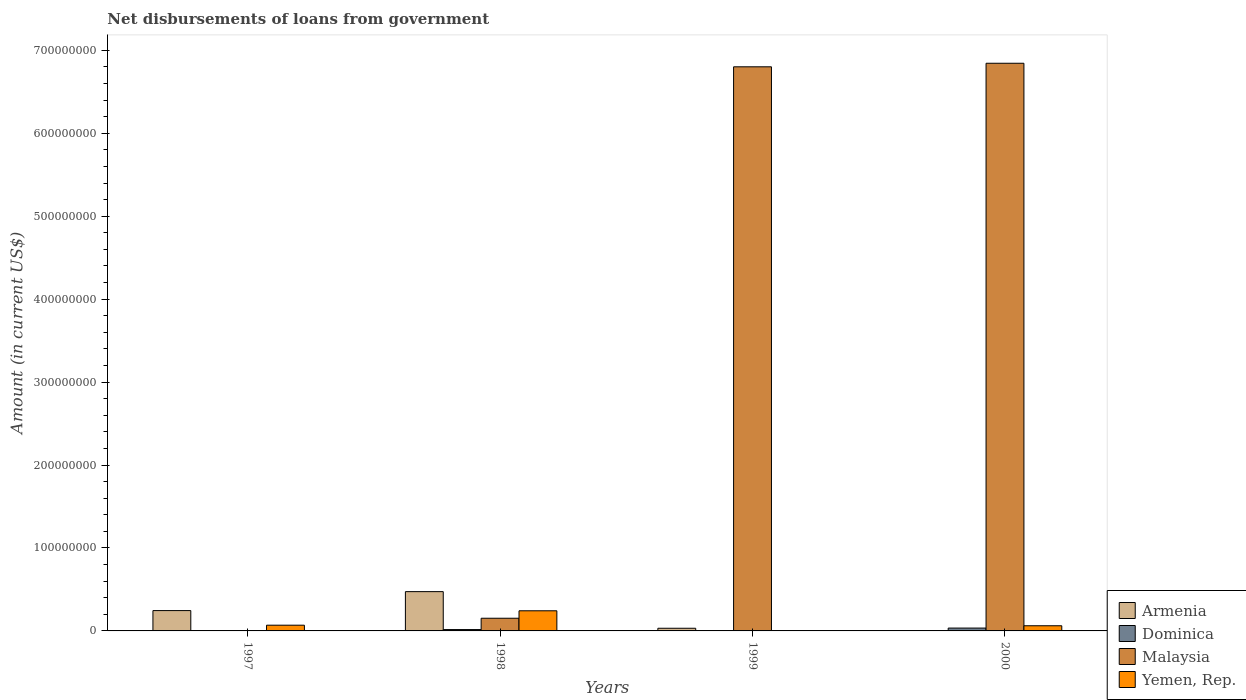How many different coloured bars are there?
Your answer should be very brief. 4. Are the number of bars per tick equal to the number of legend labels?
Make the answer very short. No. How many bars are there on the 1st tick from the left?
Provide a short and direct response. 2. How many bars are there on the 3rd tick from the right?
Provide a short and direct response. 4. What is the label of the 1st group of bars from the left?
Ensure brevity in your answer.  1997. What is the amount of loan disbursed from government in Dominica in 1999?
Offer a terse response. 0. Across all years, what is the maximum amount of loan disbursed from government in Yemen, Rep.?
Give a very brief answer. 2.43e+07. In which year was the amount of loan disbursed from government in Yemen, Rep. maximum?
Your response must be concise. 1998. What is the total amount of loan disbursed from government in Malaysia in the graph?
Keep it short and to the point. 1.38e+09. What is the difference between the amount of loan disbursed from government in Yemen, Rep. in 1997 and that in 2000?
Offer a terse response. 6.73e+05. What is the difference between the amount of loan disbursed from government in Armenia in 1998 and the amount of loan disbursed from government in Malaysia in 1997?
Ensure brevity in your answer.  4.74e+07. What is the average amount of loan disbursed from government in Malaysia per year?
Provide a succinct answer. 3.45e+08. In the year 1998, what is the difference between the amount of loan disbursed from government in Dominica and amount of loan disbursed from government in Malaysia?
Give a very brief answer. -1.37e+07. What is the ratio of the amount of loan disbursed from government in Armenia in 1997 to that in 1998?
Your answer should be very brief. 0.52. Is the difference between the amount of loan disbursed from government in Dominica in 1998 and 2000 greater than the difference between the amount of loan disbursed from government in Malaysia in 1998 and 2000?
Your answer should be compact. Yes. What is the difference between the highest and the second highest amount of loan disbursed from government in Armenia?
Your answer should be very brief. 2.28e+07. What is the difference between the highest and the lowest amount of loan disbursed from government in Armenia?
Give a very brief answer. 4.74e+07. In how many years, is the amount of loan disbursed from government in Armenia greater than the average amount of loan disbursed from government in Armenia taken over all years?
Offer a terse response. 2. Is the sum of the amount of loan disbursed from government in Malaysia in 1998 and 1999 greater than the maximum amount of loan disbursed from government in Dominica across all years?
Your answer should be compact. Yes. Is it the case that in every year, the sum of the amount of loan disbursed from government in Yemen, Rep. and amount of loan disbursed from government in Armenia is greater than the sum of amount of loan disbursed from government in Dominica and amount of loan disbursed from government in Malaysia?
Make the answer very short. No. Is it the case that in every year, the sum of the amount of loan disbursed from government in Malaysia and amount of loan disbursed from government in Yemen, Rep. is greater than the amount of loan disbursed from government in Armenia?
Give a very brief answer. No. What is the difference between two consecutive major ticks on the Y-axis?
Provide a succinct answer. 1.00e+08. Are the values on the major ticks of Y-axis written in scientific E-notation?
Your answer should be compact. No. Does the graph contain any zero values?
Keep it short and to the point. Yes. Does the graph contain grids?
Provide a short and direct response. No. Where does the legend appear in the graph?
Ensure brevity in your answer.  Bottom right. How many legend labels are there?
Give a very brief answer. 4. What is the title of the graph?
Offer a very short reply. Net disbursements of loans from government. Does "Cameroon" appear as one of the legend labels in the graph?
Provide a succinct answer. No. What is the label or title of the Y-axis?
Provide a short and direct response. Amount (in current US$). What is the Amount (in current US$) of Armenia in 1997?
Give a very brief answer. 2.45e+07. What is the Amount (in current US$) in Dominica in 1997?
Give a very brief answer. 0. What is the Amount (in current US$) of Yemen, Rep. in 1997?
Provide a succinct answer. 6.90e+06. What is the Amount (in current US$) in Armenia in 1998?
Offer a very short reply. 4.74e+07. What is the Amount (in current US$) of Dominica in 1998?
Your answer should be very brief. 1.63e+06. What is the Amount (in current US$) of Malaysia in 1998?
Make the answer very short. 1.53e+07. What is the Amount (in current US$) of Yemen, Rep. in 1998?
Your response must be concise. 2.43e+07. What is the Amount (in current US$) in Armenia in 1999?
Make the answer very short. 3.22e+06. What is the Amount (in current US$) of Malaysia in 1999?
Provide a short and direct response. 6.80e+08. What is the Amount (in current US$) of Dominica in 2000?
Your answer should be very brief. 3.44e+06. What is the Amount (in current US$) in Malaysia in 2000?
Give a very brief answer. 6.84e+08. What is the Amount (in current US$) of Yemen, Rep. in 2000?
Offer a terse response. 6.22e+06. Across all years, what is the maximum Amount (in current US$) of Armenia?
Offer a very short reply. 4.74e+07. Across all years, what is the maximum Amount (in current US$) in Dominica?
Provide a succinct answer. 3.44e+06. Across all years, what is the maximum Amount (in current US$) of Malaysia?
Provide a succinct answer. 6.84e+08. Across all years, what is the maximum Amount (in current US$) of Yemen, Rep.?
Make the answer very short. 2.43e+07. Across all years, what is the minimum Amount (in current US$) in Dominica?
Make the answer very short. 0. Across all years, what is the minimum Amount (in current US$) in Yemen, Rep.?
Your answer should be very brief. 0. What is the total Amount (in current US$) of Armenia in the graph?
Provide a succinct answer. 7.51e+07. What is the total Amount (in current US$) of Dominica in the graph?
Offer a terse response. 5.06e+06. What is the total Amount (in current US$) in Malaysia in the graph?
Make the answer very short. 1.38e+09. What is the total Amount (in current US$) in Yemen, Rep. in the graph?
Offer a terse response. 3.74e+07. What is the difference between the Amount (in current US$) of Armenia in 1997 and that in 1998?
Offer a very short reply. -2.28e+07. What is the difference between the Amount (in current US$) of Yemen, Rep. in 1997 and that in 1998?
Make the answer very short. -1.74e+07. What is the difference between the Amount (in current US$) of Armenia in 1997 and that in 1999?
Offer a very short reply. 2.13e+07. What is the difference between the Amount (in current US$) in Yemen, Rep. in 1997 and that in 2000?
Offer a very short reply. 6.73e+05. What is the difference between the Amount (in current US$) in Armenia in 1998 and that in 1999?
Make the answer very short. 4.41e+07. What is the difference between the Amount (in current US$) in Malaysia in 1998 and that in 1999?
Offer a terse response. -6.65e+08. What is the difference between the Amount (in current US$) of Dominica in 1998 and that in 2000?
Provide a short and direct response. -1.81e+06. What is the difference between the Amount (in current US$) of Malaysia in 1998 and that in 2000?
Give a very brief answer. -6.69e+08. What is the difference between the Amount (in current US$) in Yemen, Rep. in 1998 and that in 2000?
Ensure brevity in your answer.  1.81e+07. What is the difference between the Amount (in current US$) of Malaysia in 1999 and that in 2000?
Your response must be concise. -4.28e+06. What is the difference between the Amount (in current US$) of Armenia in 1997 and the Amount (in current US$) of Dominica in 1998?
Offer a very short reply. 2.29e+07. What is the difference between the Amount (in current US$) in Armenia in 1997 and the Amount (in current US$) in Malaysia in 1998?
Your response must be concise. 9.23e+06. What is the difference between the Amount (in current US$) in Armenia in 1997 and the Amount (in current US$) in Yemen, Rep. in 1998?
Offer a terse response. 2.37e+05. What is the difference between the Amount (in current US$) of Armenia in 1997 and the Amount (in current US$) of Malaysia in 1999?
Keep it short and to the point. -6.56e+08. What is the difference between the Amount (in current US$) in Armenia in 1997 and the Amount (in current US$) in Dominica in 2000?
Make the answer very short. 2.11e+07. What is the difference between the Amount (in current US$) of Armenia in 1997 and the Amount (in current US$) of Malaysia in 2000?
Give a very brief answer. -6.60e+08. What is the difference between the Amount (in current US$) in Armenia in 1997 and the Amount (in current US$) in Yemen, Rep. in 2000?
Ensure brevity in your answer.  1.83e+07. What is the difference between the Amount (in current US$) of Armenia in 1998 and the Amount (in current US$) of Malaysia in 1999?
Give a very brief answer. -6.33e+08. What is the difference between the Amount (in current US$) in Dominica in 1998 and the Amount (in current US$) in Malaysia in 1999?
Ensure brevity in your answer.  -6.79e+08. What is the difference between the Amount (in current US$) of Armenia in 1998 and the Amount (in current US$) of Dominica in 2000?
Provide a succinct answer. 4.39e+07. What is the difference between the Amount (in current US$) in Armenia in 1998 and the Amount (in current US$) in Malaysia in 2000?
Your response must be concise. -6.37e+08. What is the difference between the Amount (in current US$) in Armenia in 1998 and the Amount (in current US$) in Yemen, Rep. in 2000?
Your answer should be compact. 4.11e+07. What is the difference between the Amount (in current US$) of Dominica in 1998 and the Amount (in current US$) of Malaysia in 2000?
Your response must be concise. -6.83e+08. What is the difference between the Amount (in current US$) of Dominica in 1998 and the Amount (in current US$) of Yemen, Rep. in 2000?
Make the answer very short. -4.60e+06. What is the difference between the Amount (in current US$) of Malaysia in 1998 and the Amount (in current US$) of Yemen, Rep. in 2000?
Provide a succinct answer. 9.07e+06. What is the difference between the Amount (in current US$) of Armenia in 1999 and the Amount (in current US$) of Malaysia in 2000?
Offer a very short reply. -6.81e+08. What is the difference between the Amount (in current US$) of Armenia in 1999 and the Amount (in current US$) of Yemen, Rep. in 2000?
Offer a terse response. -3.01e+06. What is the difference between the Amount (in current US$) in Malaysia in 1999 and the Amount (in current US$) in Yemen, Rep. in 2000?
Ensure brevity in your answer.  6.74e+08. What is the average Amount (in current US$) of Armenia per year?
Make the answer very short. 1.88e+07. What is the average Amount (in current US$) in Dominica per year?
Your answer should be very brief. 1.27e+06. What is the average Amount (in current US$) of Malaysia per year?
Offer a very short reply. 3.45e+08. What is the average Amount (in current US$) in Yemen, Rep. per year?
Make the answer very short. 9.35e+06. In the year 1997, what is the difference between the Amount (in current US$) of Armenia and Amount (in current US$) of Yemen, Rep.?
Ensure brevity in your answer.  1.76e+07. In the year 1998, what is the difference between the Amount (in current US$) of Armenia and Amount (in current US$) of Dominica?
Give a very brief answer. 4.57e+07. In the year 1998, what is the difference between the Amount (in current US$) in Armenia and Amount (in current US$) in Malaysia?
Provide a succinct answer. 3.21e+07. In the year 1998, what is the difference between the Amount (in current US$) of Armenia and Amount (in current US$) of Yemen, Rep.?
Offer a terse response. 2.31e+07. In the year 1998, what is the difference between the Amount (in current US$) of Dominica and Amount (in current US$) of Malaysia?
Make the answer very short. -1.37e+07. In the year 1998, what is the difference between the Amount (in current US$) in Dominica and Amount (in current US$) in Yemen, Rep.?
Keep it short and to the point. -2.27e+07. In the year 1998, what is the difference between the Amount (in current US$) of Malaysia and Amount (in current US$) of Yemen, Rep.?
Ensure brevity in your answer.  -8.99e+06. In the year 1999, what is the difference between the Amount (in current US$) in Armenia and Amount (in current US$) in Malaysia?
Provide a succinct answer. -6.77e+08. In the year 2000, what is the difference between the Amount (in current US$) of Dominica and Amount (in current US$) of Malaysia?
Provide a short and direct response. -6.81e+08. In the year 2000, what is the difference between the Amount (in current US$) in Dominica and Amount (in current US$) in Yemen, Rep.?
Your response must be concise. -2.79e+06. In the year 2000, what is the difference between the Amount (in current US$) of Malaysia and Amount (in current US$) of Yemen, Rep.?
Give a very brief answer. 6.78e+08. What is the ratio of the Amount (in current US$) in Armenia in 1997 to that in 1998?
Keep it short and to the point. 0.52. What is the ratio of the Amount (in current US$) of Yemen, Rep. in 1997 to that in 1998?
Keep it short and to the point. 0.28. What is the ratio of the Amount (in current US$) in Armenia in 1997 to that in 1999?
Ensure brevity in your answer.  7.63. What is the ratio of the Amount (in current US$) of Yemen, Rep. in 1997 to that in 2000?
Your answer should be compact. 1.11. What is the ratio of the Amount (in current US$) in Armenia in 1998 to that in 1999?
Offer a terse response. 14.73. What is the ratio of the Amount (in current US$) of Malaysia in 1998 to that in 1999?
Ensure brevity in your answer.  0.02. What is the ratio of the Amount (in current US$) in Dominica in 1998 to that in 2000?
Make the answer very short. 0.47. What is the ratio of the Amount (in current US$) of Malaysia in 1998 to that in 2000?
Ensure brevity in your answer.  0.02. What is the ratio of the Amount (in current US$) in Yemen, Rep. in 1998 to that in 2000?
Provide a succinct answer. 3.9. What is the difference between the highest and the second highest Amount (in current US$) of Armenia?
Give a very brief answer. 2.28e+07. What is the difference between the highest and the second highest Amount (in current US$) of Malaysia?
Your response must be concise. 4.28e+06. What is the difference between the highest and the second highest Amount (in current US$) in Yemen, Rep.?
Keep it short and to the point. 1.74e+07. What is the difference between the highest and the lowest Amount (in current US$) of Armenia?
Offer a terse response. 4.74e+07. What is the difference between the highest and the lowest Amount (in current US$) in Dominica?
Your answer should be compact. 3.44e+06. What is the difference between the highest and the lowest Amount (in current US$) in Malaysia?
Your answer should be very brief. 6.84e+08. What is the difference between the highest and the lowest Amount (in current US$) of Yemen, Rep.?
Make the answer very short. 2.43e+07. 